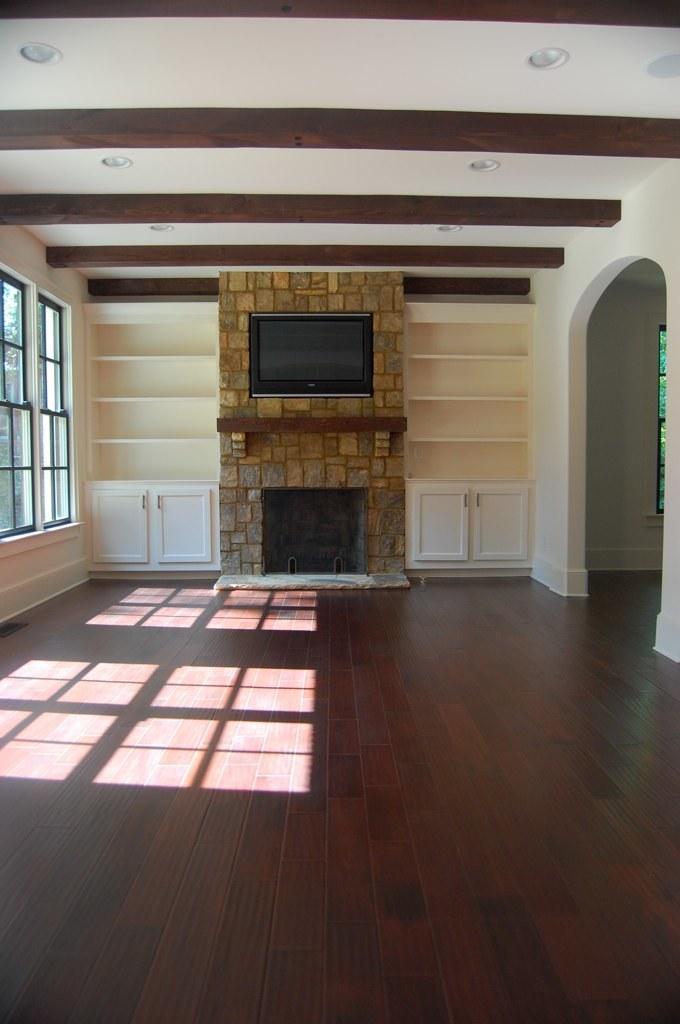Could you give a brief overview of what you see in this image? In this image in the background there is a fireplace. On the left side there are windows and on the right side there is a wall. In the background there are cupboards which are white in colour. 